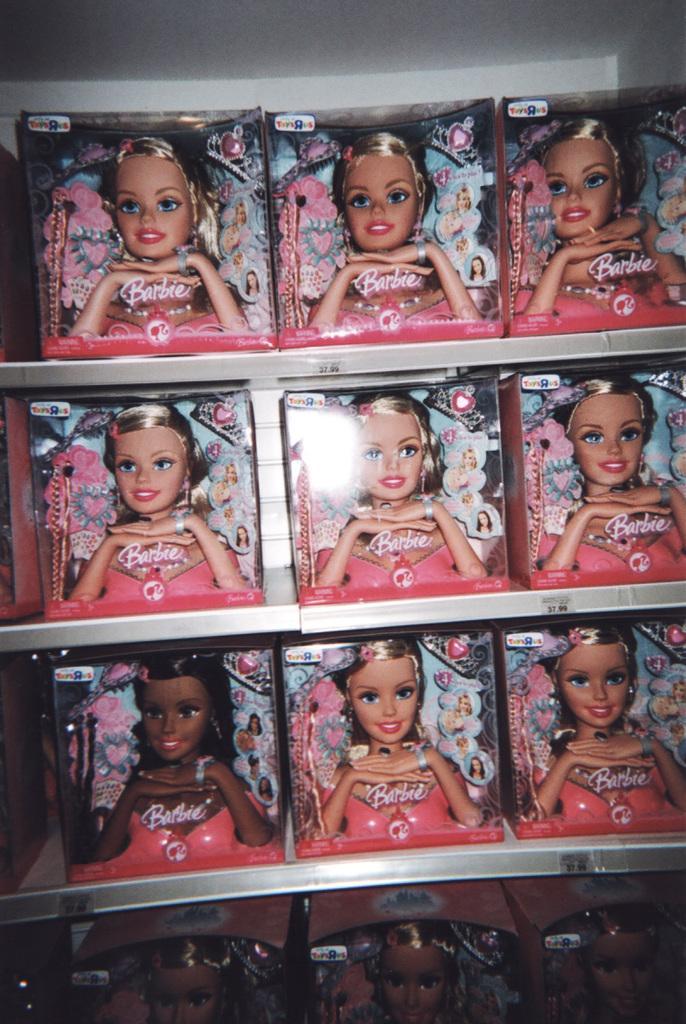Please provide a concise description of this image. In this picture we can see shelves, here we can see boxes with barbie dolls in it and we can see a wall in the background. 